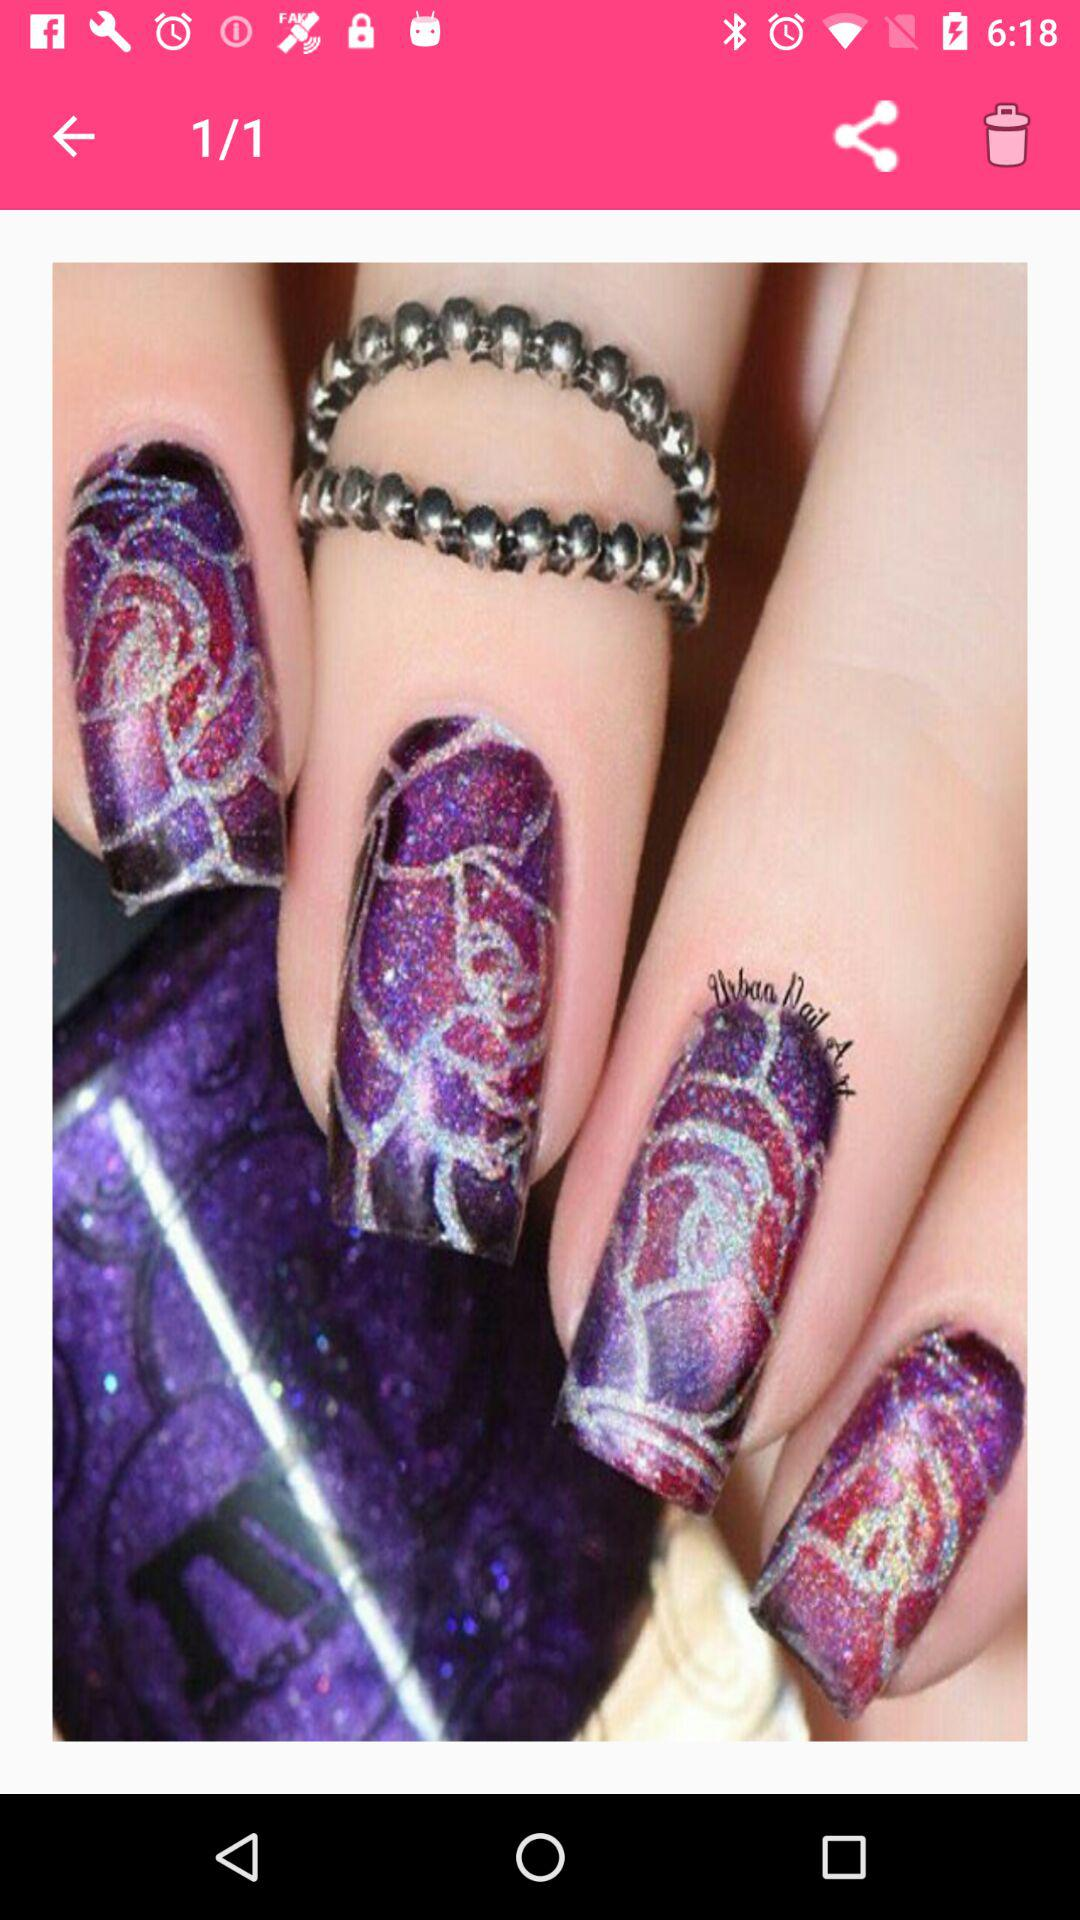How many images in total are there? There is 1 image. 